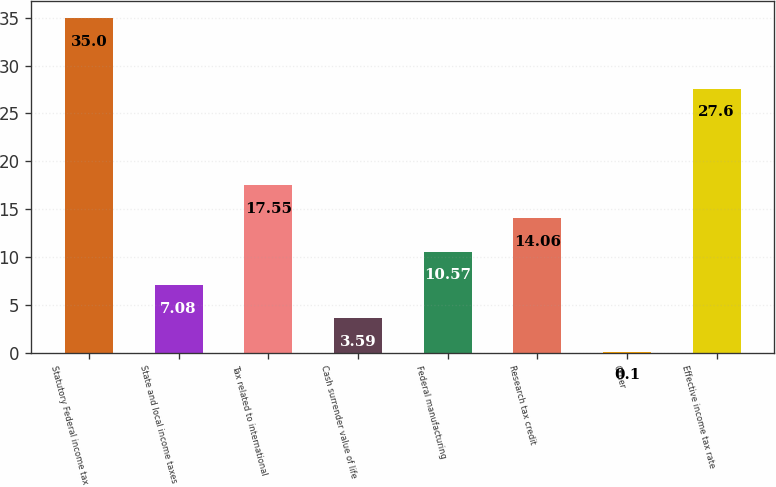Convert chart. <chart><loc_0><loc_0><loc_500><loc_500><bar_chart><fcel>Statutory Federal income tax<fcel>State and local income taxes<fcel>Tax related to international<fcel>Cash surrender value of life<fcel>Federal manufacturing<fcel>Research tax credit<fcel>Other<fcel>Effective income tax rate<nl><fcel>35<fcel>7.08<fcel>17.55<fcel>3.59<fcel>10.57<fcel>14.06<fcel>0.1<fcel>27.6<nl></chart> 